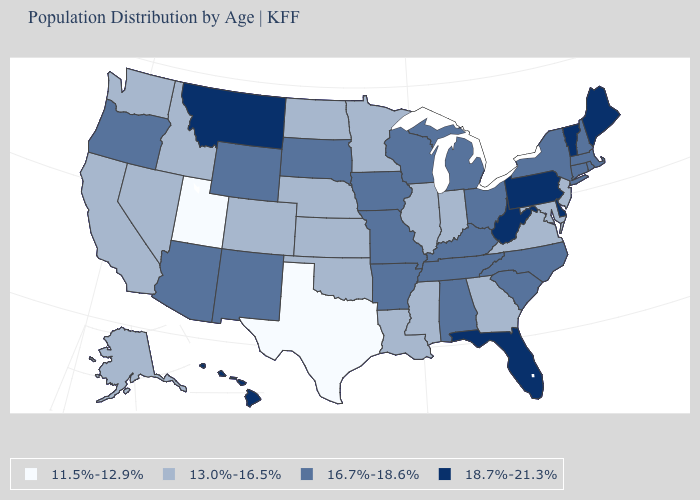What is the value of Oregon?
Quick response, please. 16.7%-18.6%. Does the first symbol in the legend represent the smallest category?
Quick response, please. Yes. What is the value of Connecticut?
Be succinct. 16.7%-18.6%. Which states have the lowest value in the West?
Short answer required. Utah. Is the legend a continuous bar?
Give a very brief answer. No. Does Texas have a lower value than West Virginia?
Quick response, please. Yes. Does the map have missing data?
Keep it brief. No. Is the legend a continuous bar?
Short answer required. No. Does Texas have the lowest value in the USA?
Give a very brief answer. Yes. Name the states that have a value in the range 18.7%-21.3%?
Short answer required. Delaware, Florida, Hawaii, Maine, Montana, Pennsylvania, Vermont, West Virginia. What is the highest value in the South ?
Give a very brief answer. 18.7%-21.3%. What is the value of Illinois?
Keep it brief. 13.0%-16.5%. What is the value of Louisiana?
Short answer required. 13.0%-16.5%. What is the value of Rhode Island?
Concise answer only. 16.7%-18.6%. What is the value of Idaho?
Give a very brief answer. 13.0%-16.5%. 